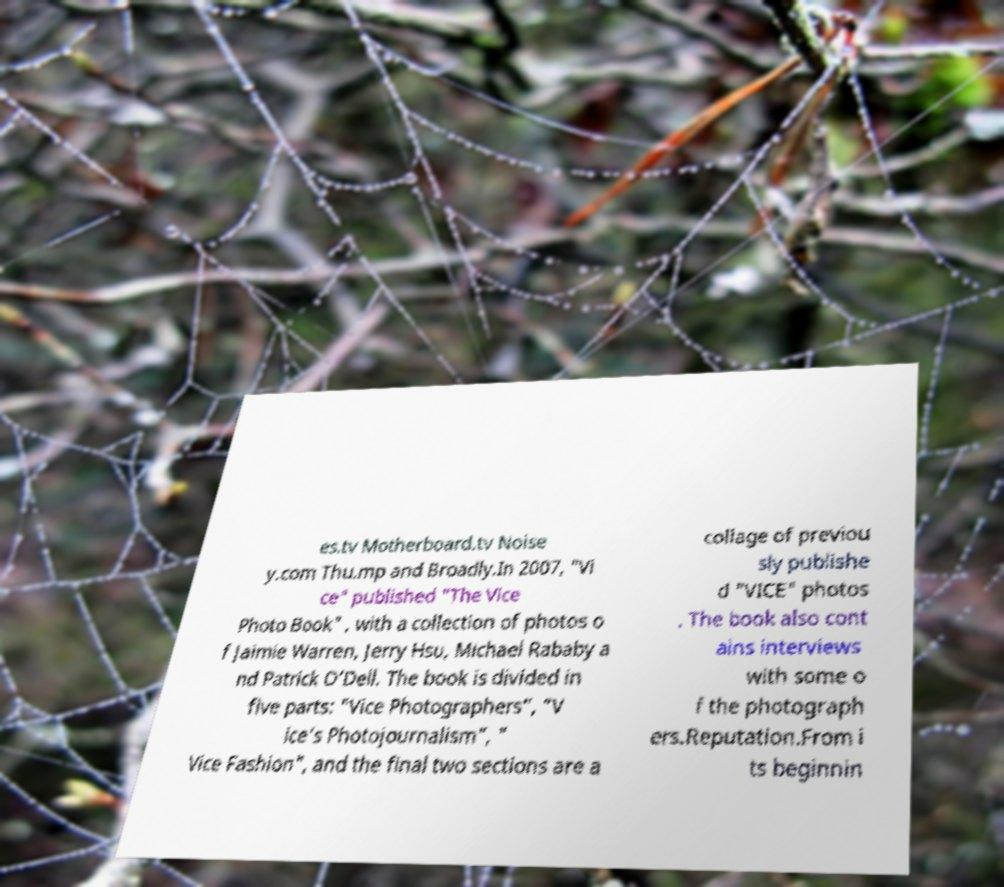Could you assist in decoding the text presented in this image and type it out clearly? es.tv Motherboard.tv Noise y.com Thu.mp and Broadly.In 2007, "Vi ce" published "The Vice Photo Book" , with a collection of photos o f Jaimie Warren, Jerry Hsu, Michael Rababy a nd Patrick O’Dell. The book is divided in five parts: "Vice Photographers”, ”V ice’s Photojournalism”, " Vice Fashion", and the final two sections are a collage of previou sly publishe d "VICE" photos . The book also cont ains interviews with some o f the photograph ers.Reputation.From i ts beginnin 